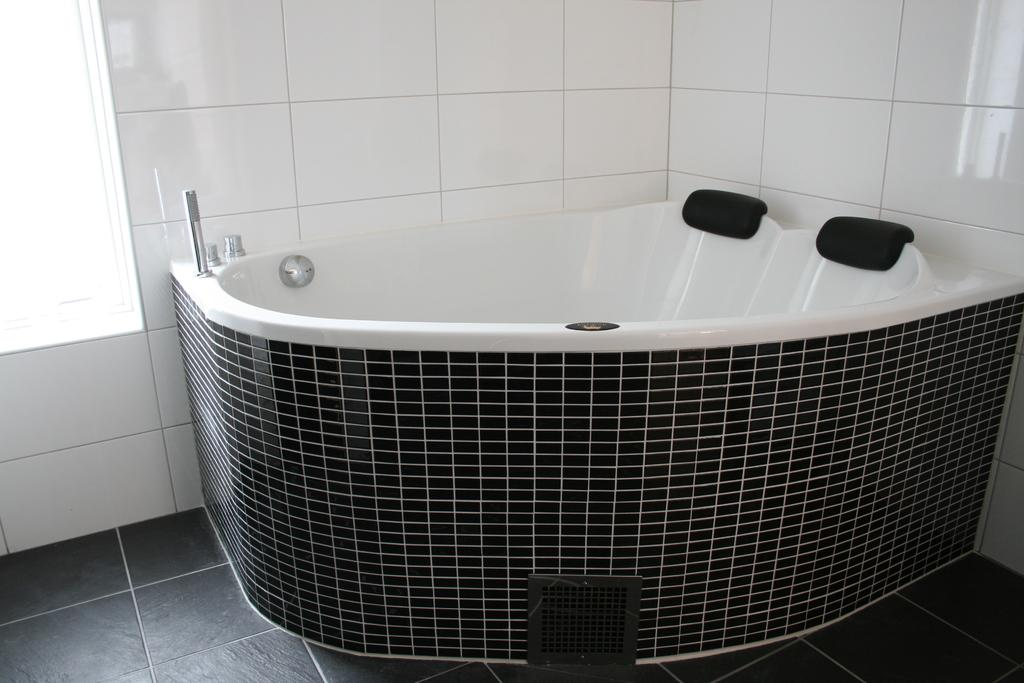What is the main object in the image? There is a bathing tube in the image. What can be seen in the background of the image? There is a wall in the background of the image. What advice is being given in the image? There is no indication of any advice being given in the image, as it primarily features a bathing tube and a wall in the background. 